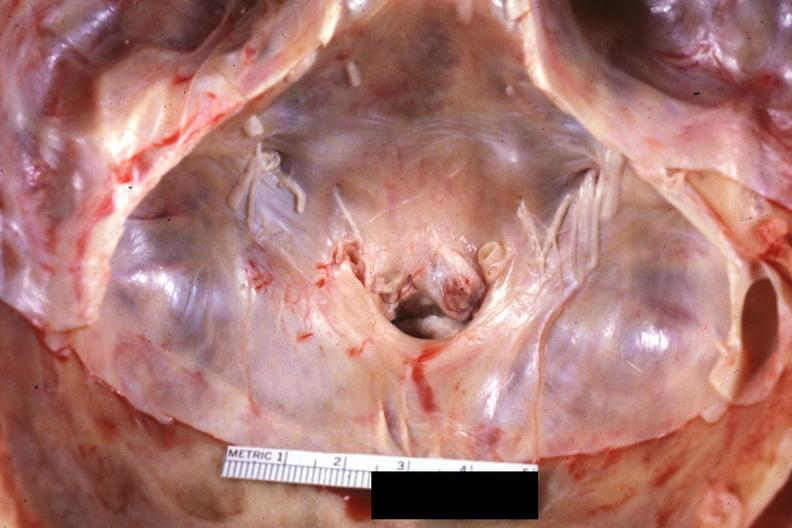what is present?
Answer the question using a single word or phrase. Bone 